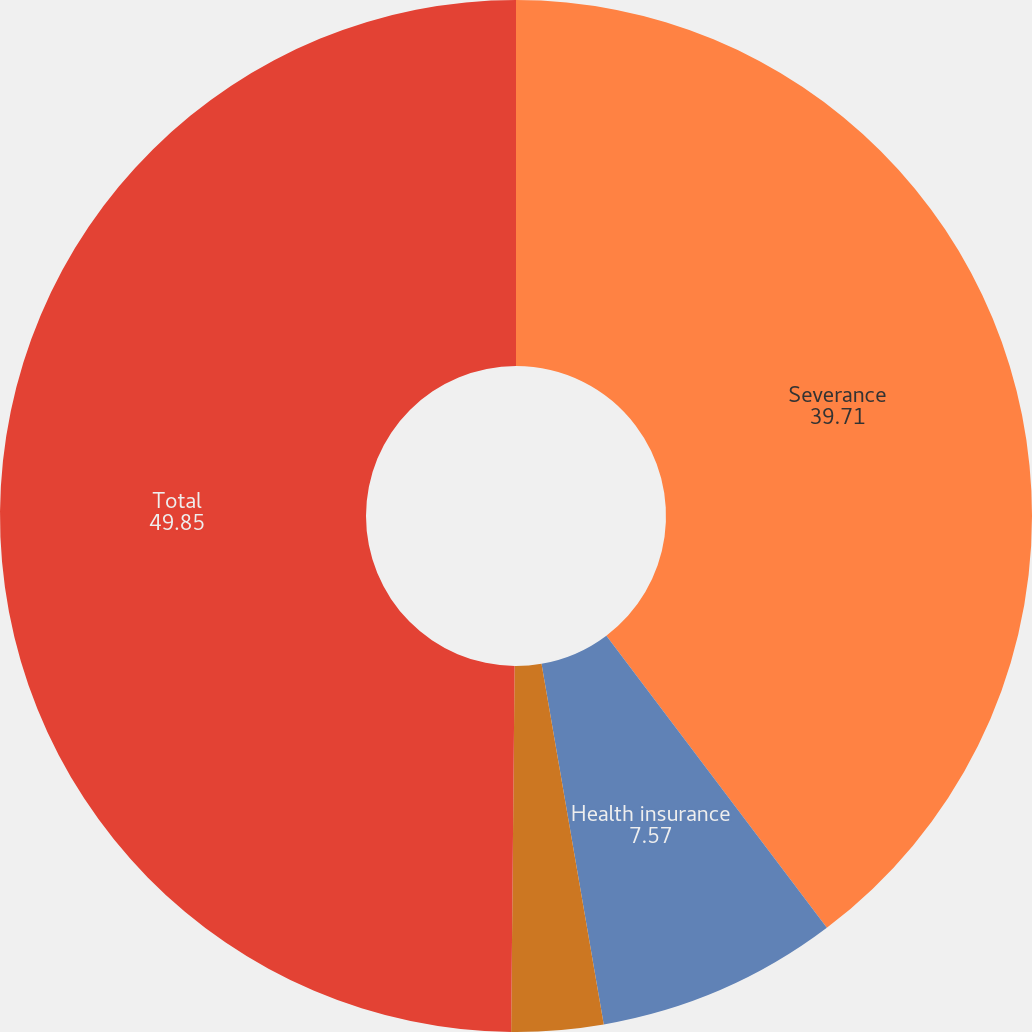Convert chart. <chart><loc_0><loc_0><loc_500><loc_500><pie_chart><fcel>Severance<fcel>Health insurance<fcel>Placement services<fcel>Total<nl><fcel>39.71%<fcel>7.57%<fcel>2.87%<fcel>49.85%<nl></chart> 